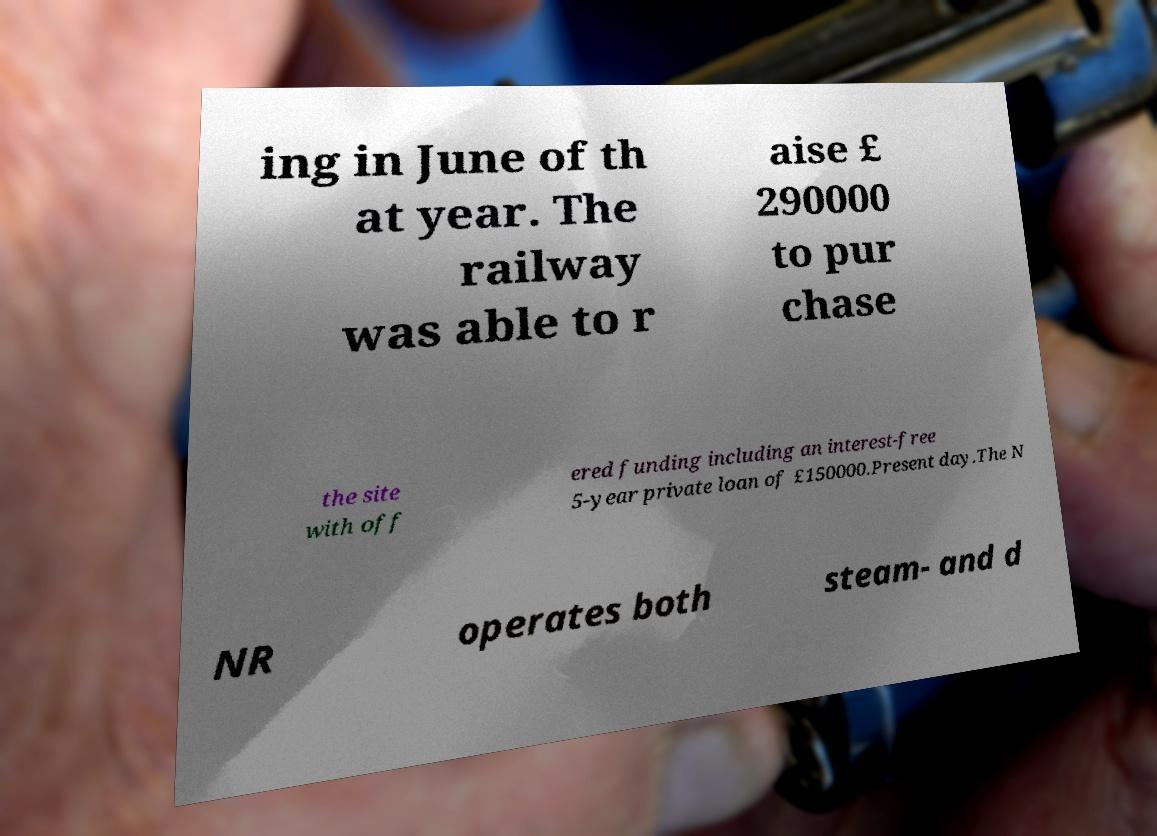Could you extract and type out the text from this image? ing in June of th at year. The railway was able to r aise £ 290000 to pur chase the site with off ered funding including an interest-free 5-year private loan of £150000.Present day.The N NR operates both steam- and d 